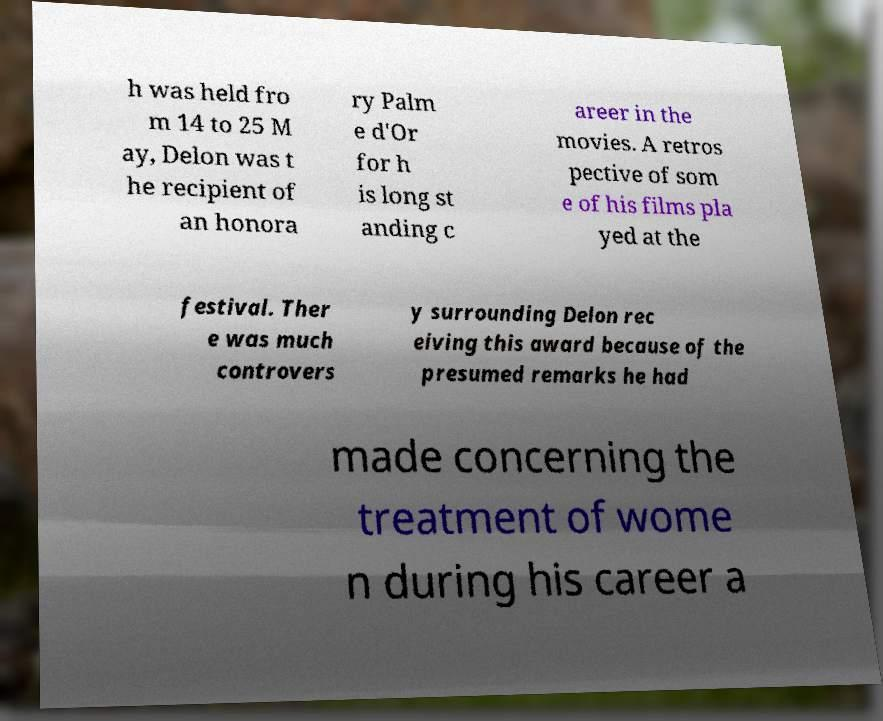I need the written content from this picture converted into text. Can you do that? h was held fro m 14 to 25 M ay, Delon was t he recipient of an honora ry Palm e d'Or for h is long st anding c areer in the movies. A retros pective of som e of his films pla yed at the festival. Ther e was much controvers y surrounding Delon rec eiving this award because of the presumed remarks he had made concerning the treatment of wome n during his career a 